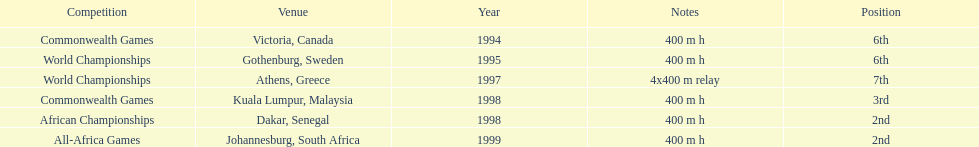Excluding 1999, when did ken harnden come in second place? 1998. 